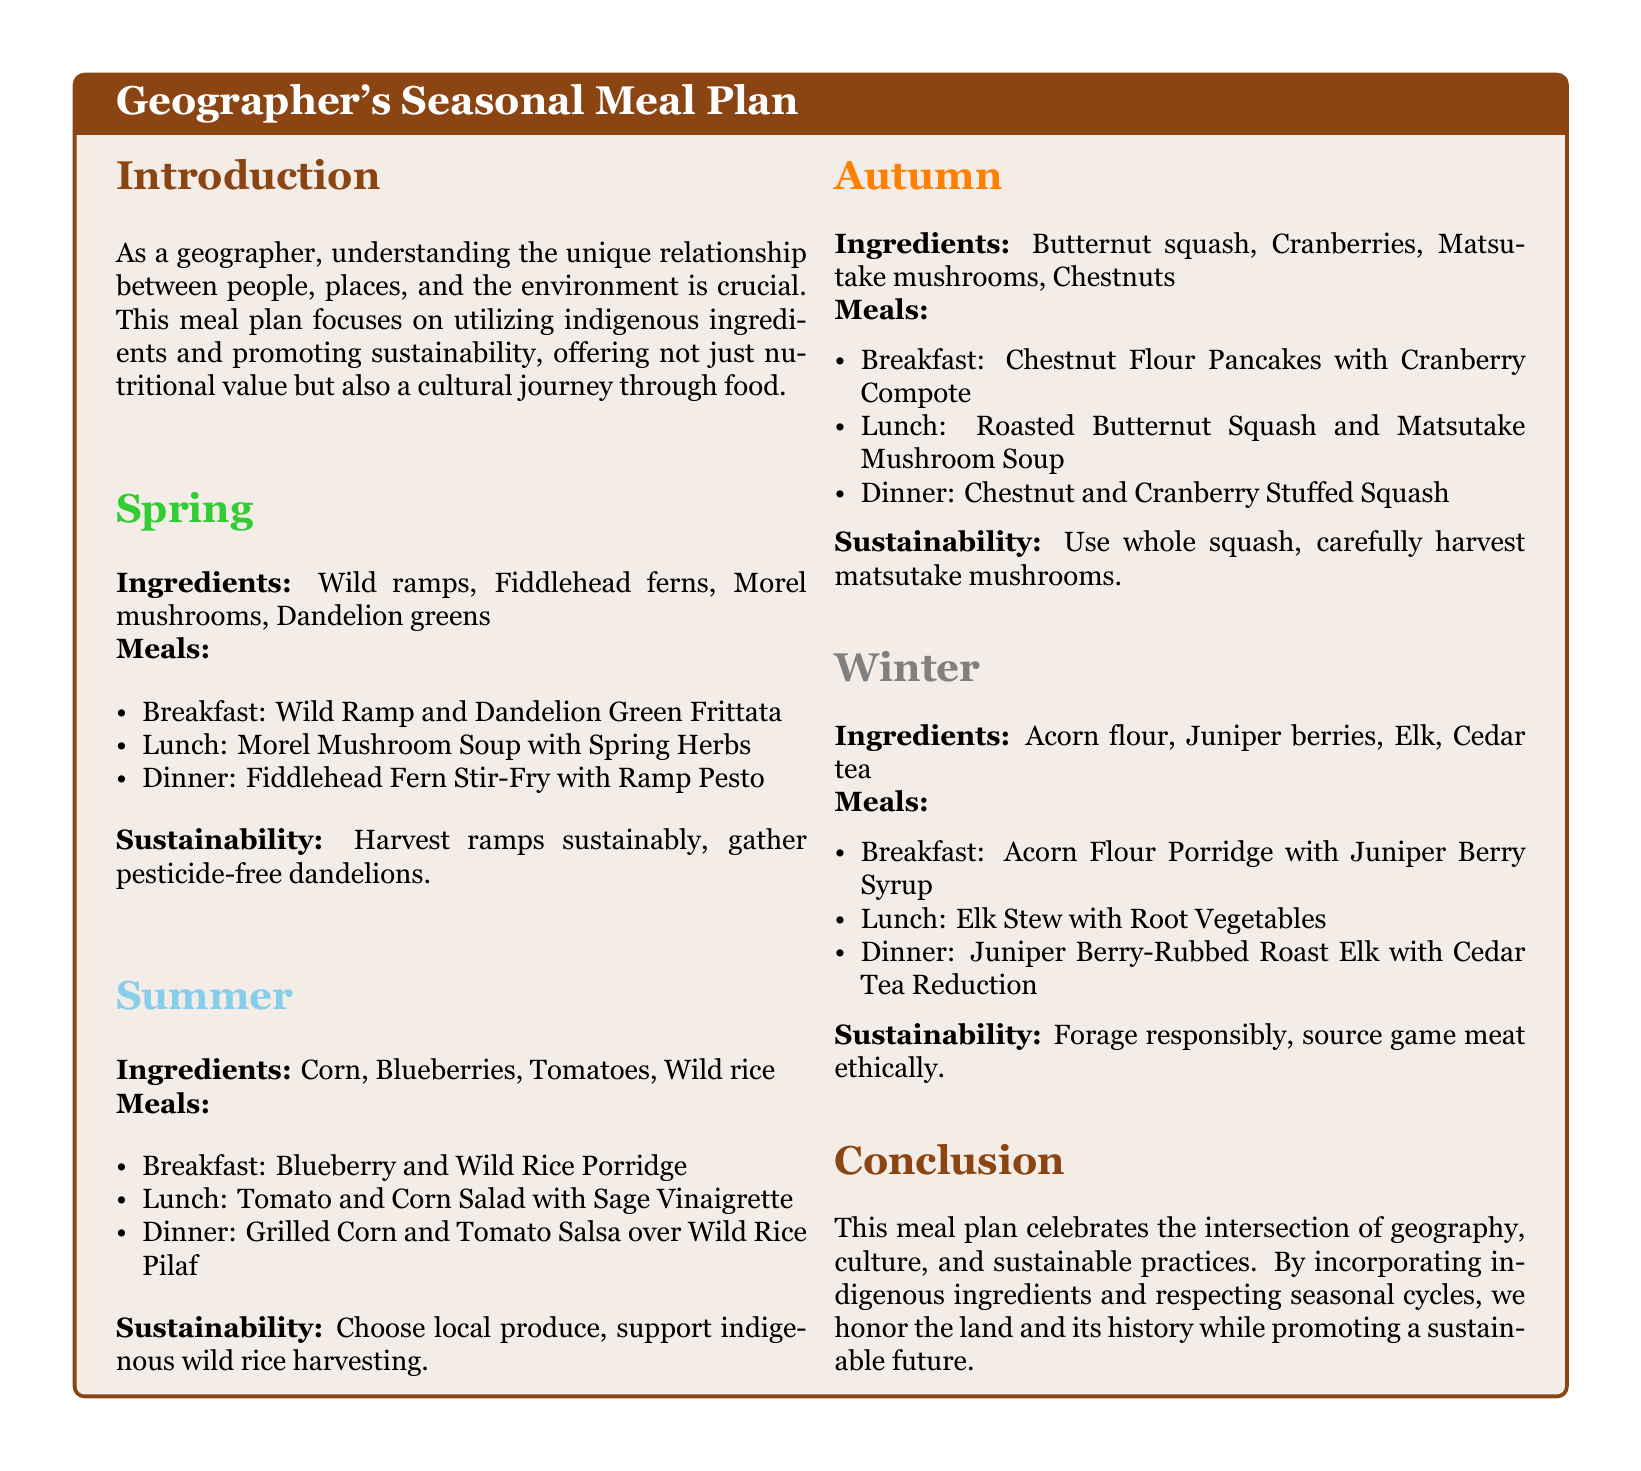What is the main focus of the meal plan? The meal plan focuses on utilizing indigenous ingredients and promoting sustainability, offering nutritional value and a cultural journey through food.
Answer: Indigenous ingredients and sustainability How many seasonal sections are in the meal plan? The meal plan contains four seasonal sections: Spring, Summer, Autumn, and Winter.
Answer: Four What ingredient is used for breakfast in Spring? The breakfast in Spring includes Wild Ramp and Dandelion Green Frittata, which features wild ramps.
Answer: Wild ramps Which meal in Winter includes elk? The lunch in Winter consists of Elk Stew with Root Vegetables, which includes elk as a primary ingredient.
Answer: Elk Stew What sustainability practice is recommended for harvesting ramps? The document suggests to harvest ramps sustainably as a sustainability practice.
Answer: Harvest sustainably What type of flour is used in the Autumn breakfast? The breakfast in Autumn features Chestnut Flour Pancakes, which indicates the use of chestnut flour.
Answer: Chestnut flour What ingredient is highlighted in Summer for a salad? The Summer lunch features Tomato and Corn Salad, highlighting tomatoes as a key ingredient.
Answer: Tomatoes Name one ingredient for Dinner in Autumn. The dinner in Autumn can include Chestnut and Cranberry Stuffed Squash, indicating chestnuts or cranberries.
Answer: Chestnuts What drink is served with dinner in Winter? The dinner in Winter is paired with Cedar Tea Reduction, which indicates cedar tea as the drink.
Answer: Cedar tea 